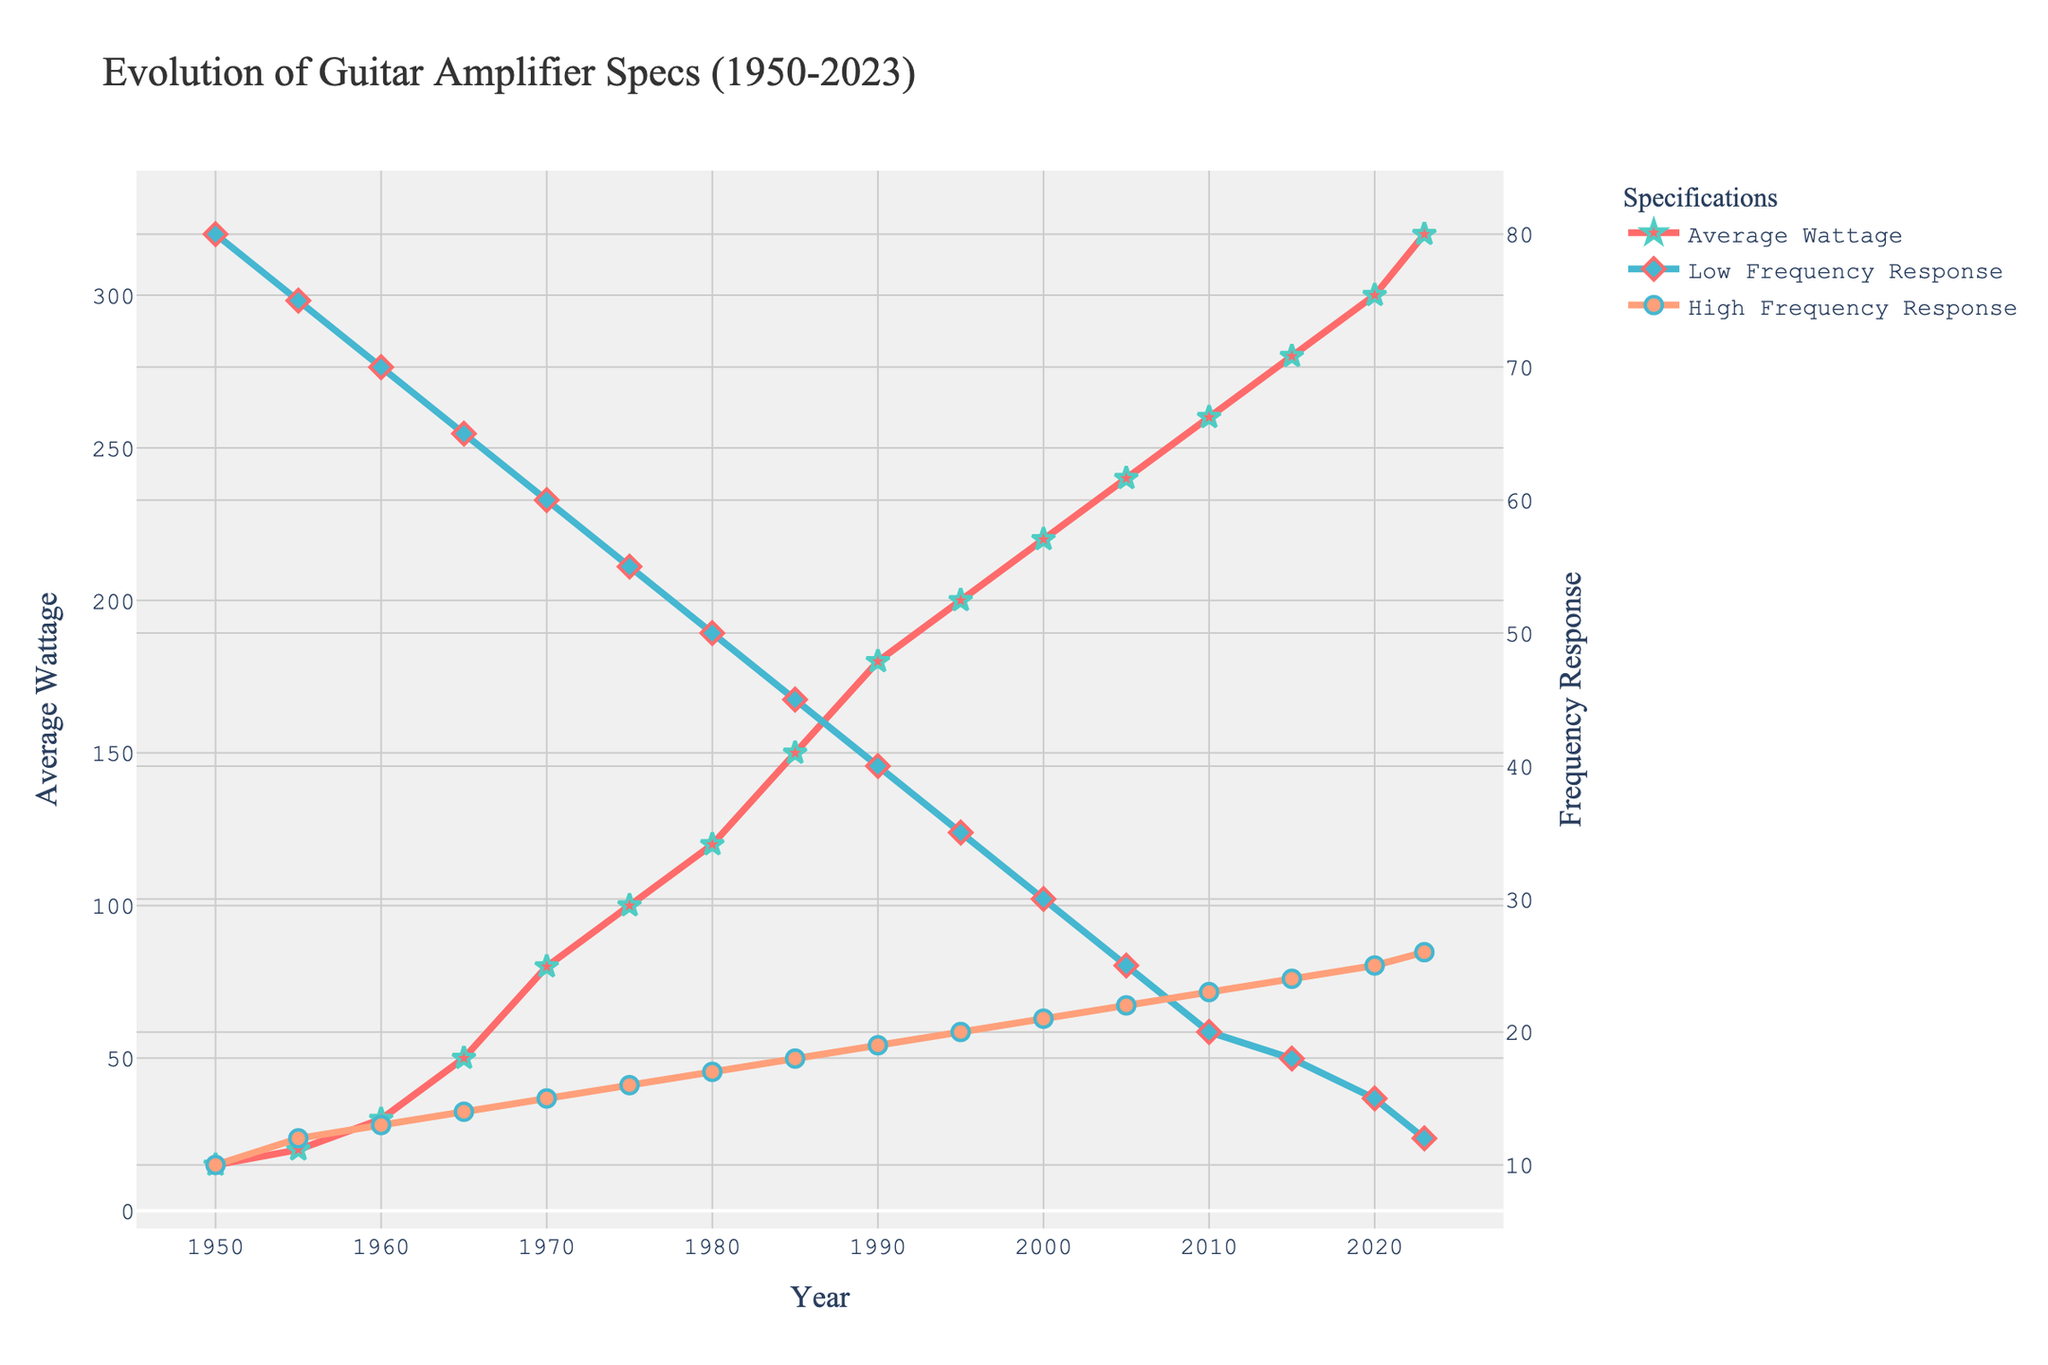What is the average wattage of guitar amplifiers in 1980? Locate the year 1980 on the x-axis and find the corresponding "Average Wattage" value on the y-axis.
Answer: 120 watts Which year saw the greatest increase in average wattage compared to the previous decade? Compare the differences in average wattage from decade to decade by checking the vertical distances between points on the "Average Wattage" line plot. The largest increase occurred between 1960 and 1970, with an increase from 30 watts to 80 watts.
Answer: 1970 How does the low-frequency response change between 1965 and 1985? Locate the years 1965 and 1985 on the x-axis and find the corresponding "Low Frequency Response" values on the secondary y-axis. Calculate the difference: 65 Hz in 1965 to 45 Hz in 1985, resulting in a decrease of 20 Hz.
Answer: Decreases by 20 Hz In 2023, is the high-frequency response greater than in 2015? Locate the years 2023 and 2015 on the x-axis and compare their corresponding "High Frequency Response" values on the secondary y-axis. The value in 2023 is 26 kHz and in 2015 is 24 kHz.
Answer: Yes Which year corresponds to the highest low-frequency response? Identify the highest point on the "Low Frequency Response" line plot, which corresponds to the highest value on the secondary y-axis. This value occurs at 80 Hz in 1950.
Answer: 1950 Calculate the average low-frequency response from 1950 to 2023. Sum all the "Low Frequency Response (Hz)" values and divide by the total number of years listed (16). \[(80 + 75 + 70 + 65 + 60 + 55 + 50 + 45 + 40 + 35 + 30 + 25 + 20 + 18 + 15 + 12) / 16 = 145 / 16 = 43 \].
Answer: 43 Hz Compare the change in high-frequency response from 1970 to 1990 to the change from 2000 to 2023. Calculate the differences separately: (1970: 15 kHz to 1990: 19 kHz) results in +4 kHz and (2000: 21 kHz to 2023: 26 kHz) results in +5 kHz, then compare these two changes.
Answer: Increase by 4 kHz vs. Increase by 5 kHz What is the visual difference between the line styles for the three different specs on the plot? Observe the colors and marker styles of the lines. "Average Wattage" uses a red line with star markers, "Low Frequency Response" uses a blue line with diamond markers, and "High Frequency Response" uses an orange line with circle markers.
Answer: Red line with stars, Blue line with diamonds, Orange line with circles 